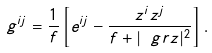Convert formula to latex. <formula><loc_0><loc_0><loc_500><loc_500>g ^ { i j } = \frac { 1 } { f } \left [ e ^ { i j } - \frac { z ^ { i } z ^ { j } } { f + | \ g r z | ^ { 2 } } \right ] .</formula> 